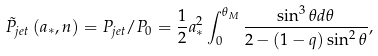Convert formula to latex. <formula><loc_0><loc_0><loc_500><loc_500>\tilde { P } _ { j e t } \left ( { a _ { * } , n } \right ) = P _ { j e t } / P _ { 0 } = \frac { 1 } { 2 } a _ { * } ^ { 2 } \int _ { 0 } ^ { \theta _ { M } } { \frac { \sin ^ { 3 } \theta d \theta } { 2 - \left ( { 1 - q } \right ) \sin ^ { 2 } \theta } } ,</formula> 